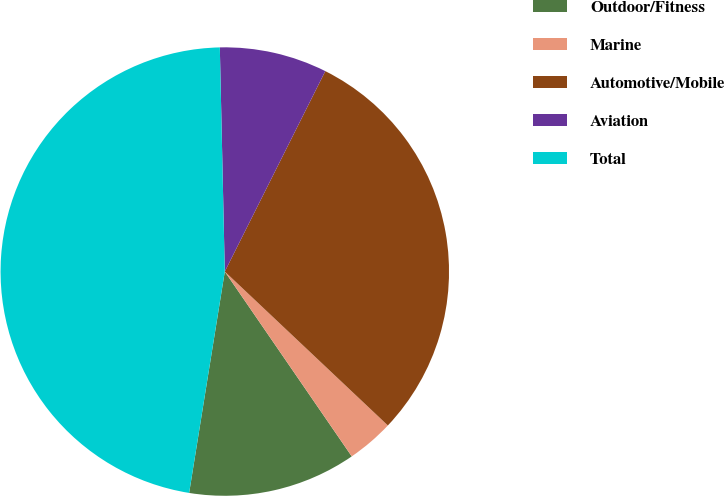Convert chart. <chart><loc_0><loc_0><loc_500><loc_500><pie_chart><fcel>Outdoor/Fitness<fcel>Marine<fcel>Automotive/Mobile<fcel>Aviation<fcel>Total<nl><fcel>12.12%<fcel>3.38%<fcel>29.64%<fcel>7.75%<fcel>47.1%<nl></chart> 